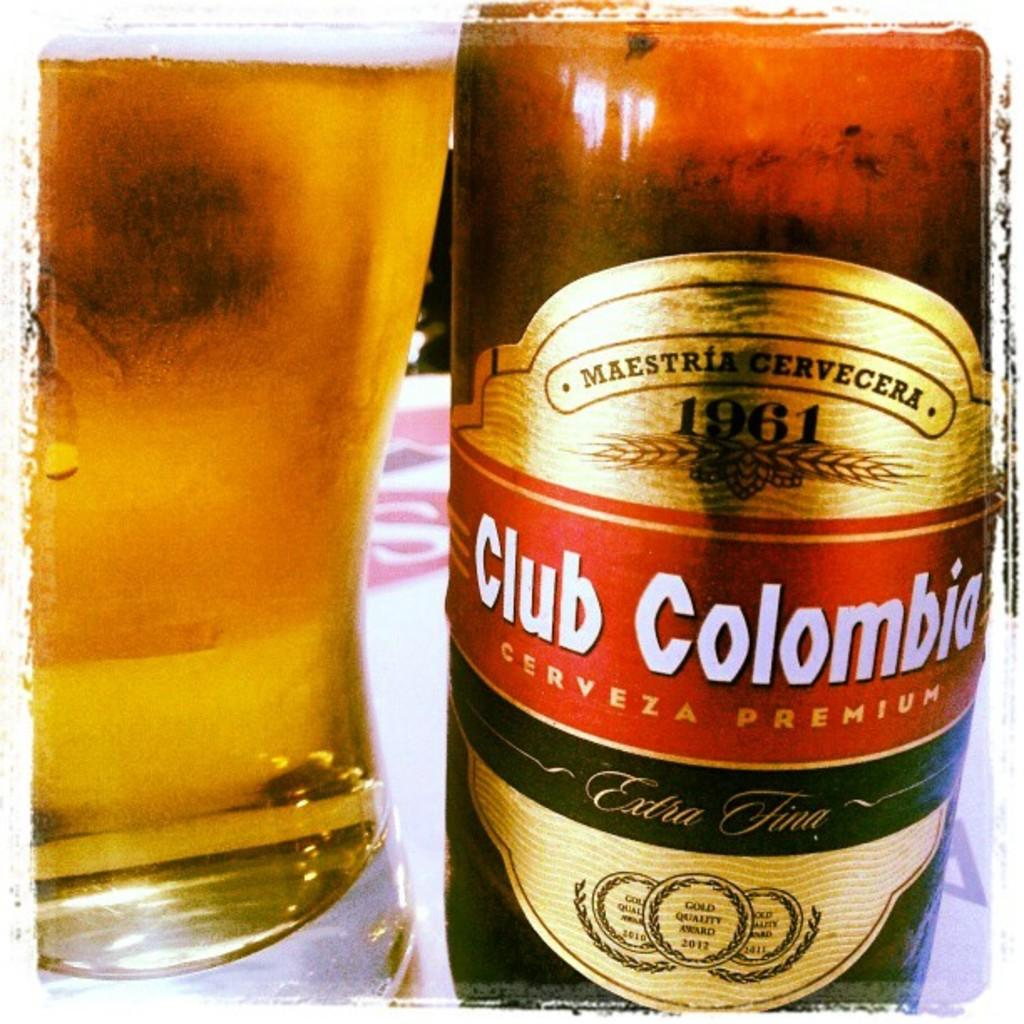<image>
Provide a brief description of the given image. A glass full of beer is next to the beer bottle of Club Colombia. 